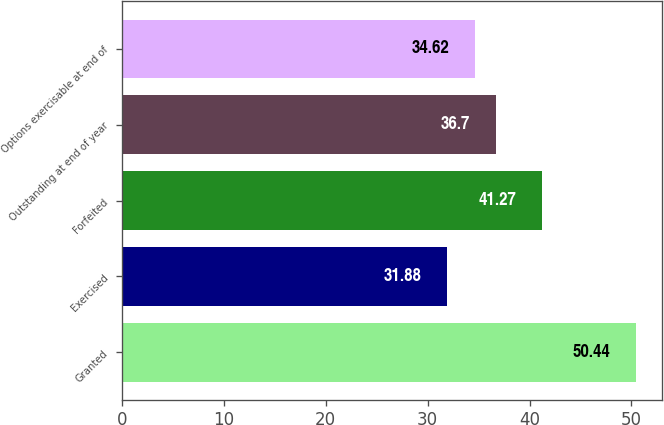Convert chart. <chart><loc_0><loc_0><loc_500><loc_500><bar_chart><fcel>Granted<fcel>Exercised<fcel>Forfeited<fcel>Outstanding at end of year<fcel>Options exercisable at end of<nl><fcel>50.44<fcel>31.88<fcel>41.27<fcel>36.7<fcel>34.62<nl></chart> 